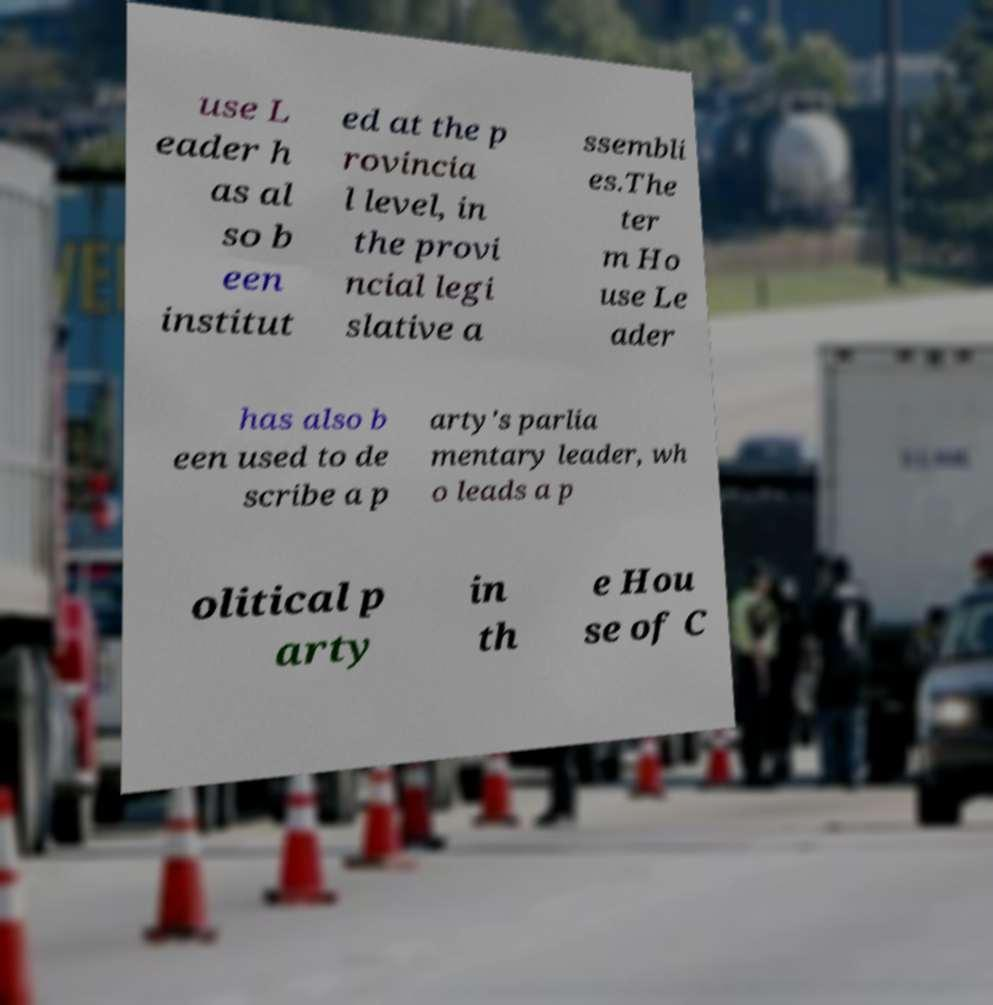Could you assist in decoding the text presented in this image and type it out clearly? use L eader h as al so b een institut ed at the p rovincia l level, in the provi ncial legi slative a ssembli es.The ter m Ho use Le ader has also b een used to de scribe a p arty's parlia mentary leader, wh o leads a p olitical p arty in th e Hou se of C 